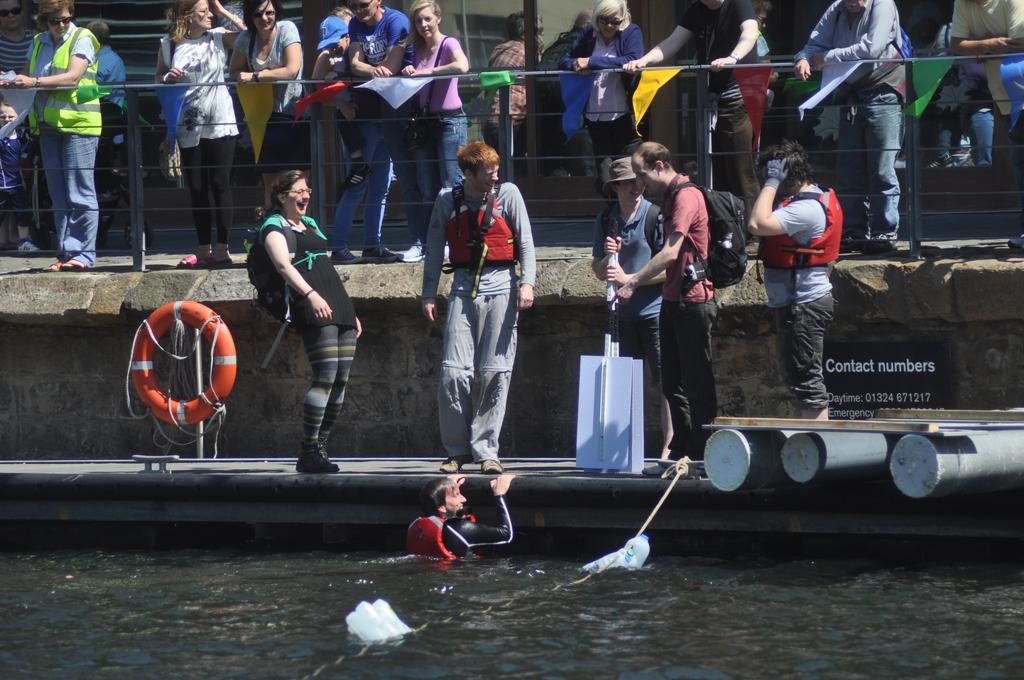Could you give a brief overview of what you see in this image? In the foreground of the picture there is a water body, in the water there are plastic cans and a person. In the center of the picture it is dock, on the dock there are people, boards and many other objects. At the top there are people standing by the railings and there are ribbons, pole, building and other objects. 